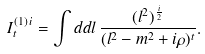Convert formula to latex. <formula><loc_0><loc_0><loc_500><loc_500>I ^ { ( 1 ) \, i } _ { t } = \int d d l \, \frac { ( l ^ { 2 } ) ^ { \frac { i } { 2 } } } { ( l ^ { 2 } - m ^ { 2 } + i \rho ) ^ { t } } .</formula> 